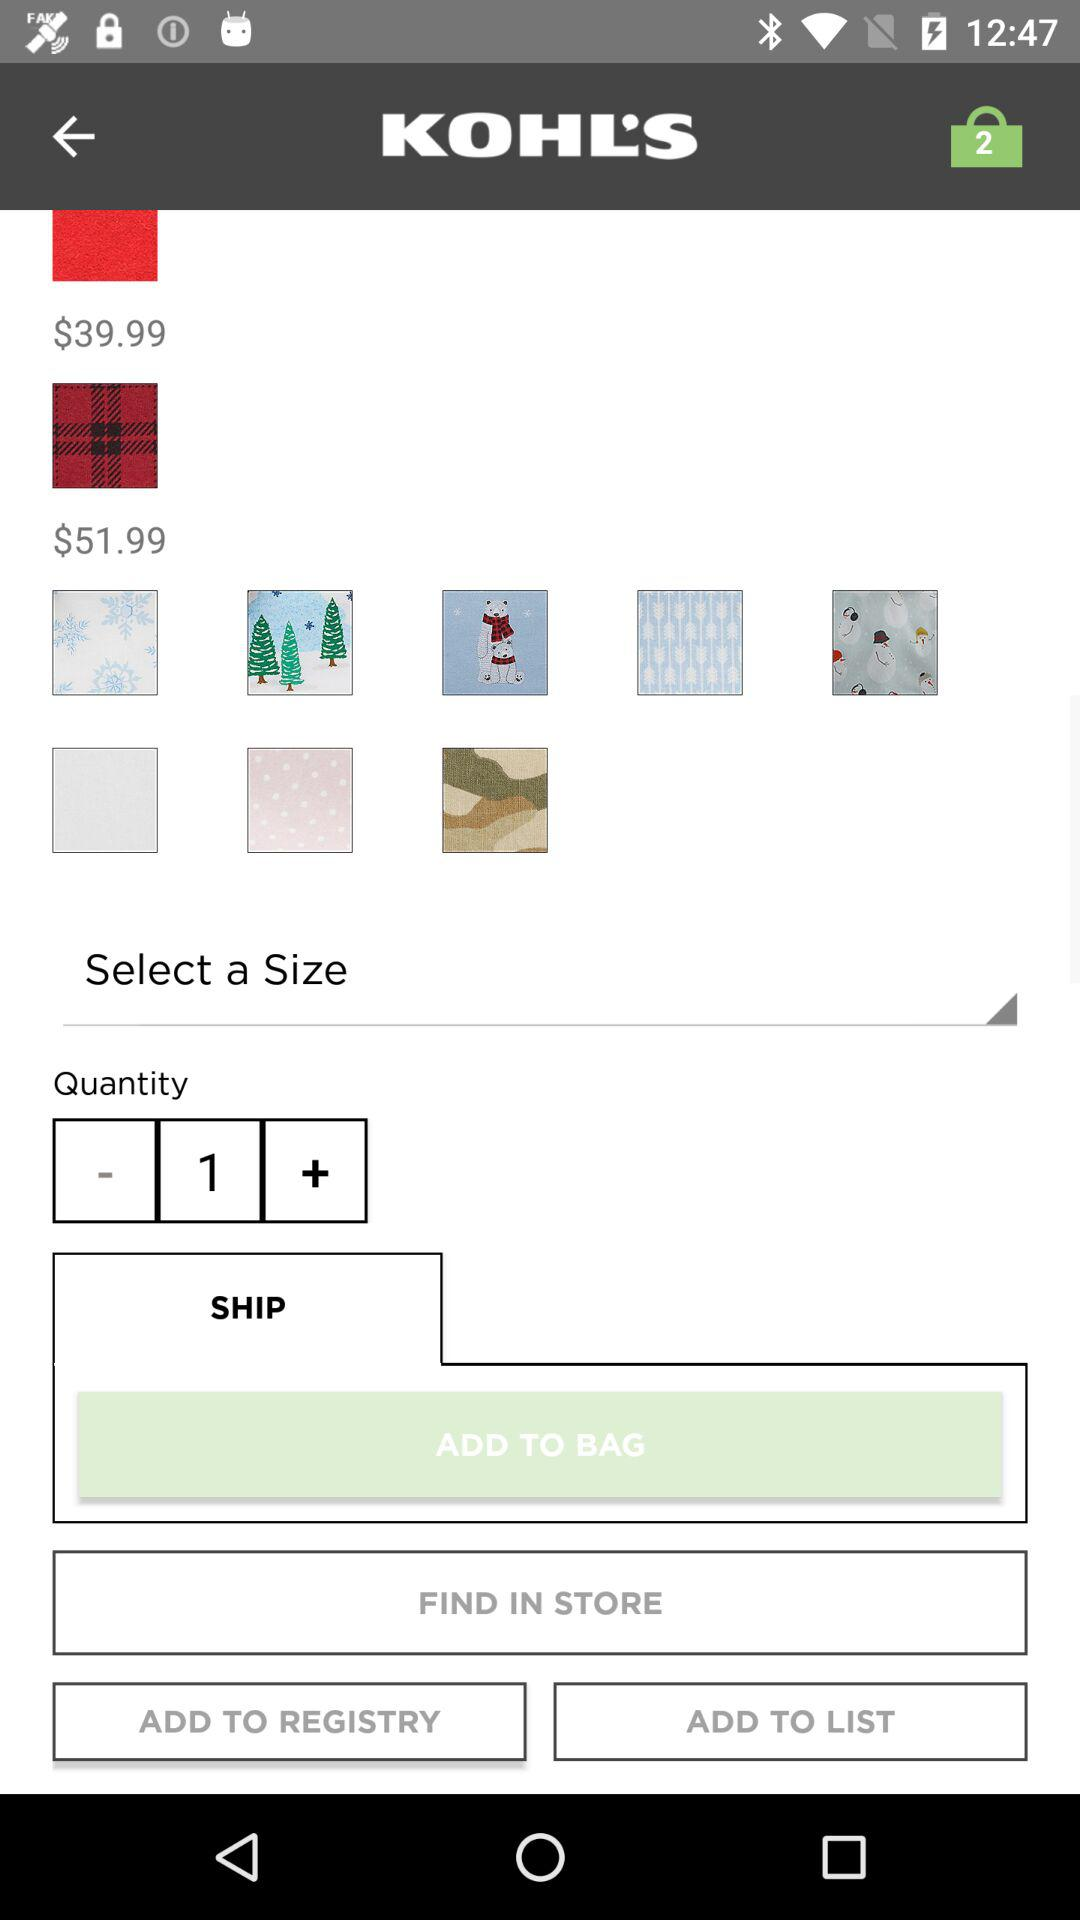How many items are in the cart? There are 2 items in the cart. 